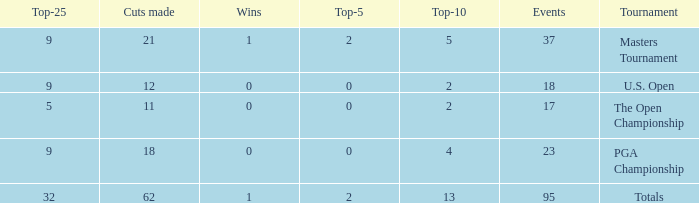What is the number of wins that is in the top 10 and larger than 13? None. 